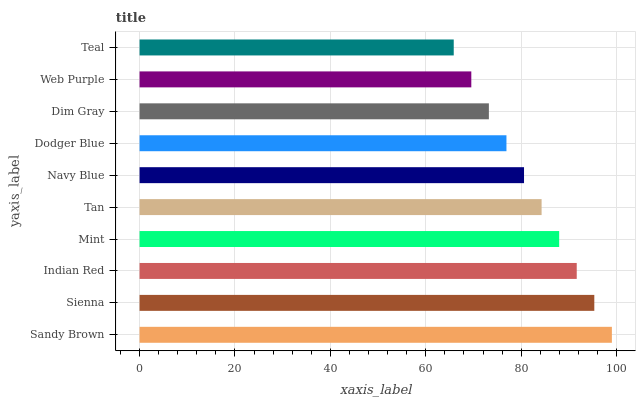Is Teal the minimum?
Answer yes or no. Yes. Is Sandy Brown the maximum?
Answer yes or no. Yes. Is Sienna the minimum?
Answer yes or no. No. Is Sienna the maximum?
Answer yes or no. No. Is Sandy Brown greater than Sienna?
Answer yes or no. Yes. Is Sienna less than Sandy Brown?
Answer yes or no. Yes. Is Sienna greater than Sandy Brown?
Answer yes or no. No. Is Sandy Brown less than Sienna?
Answer yes or no. No. Is Tan the high median?
Answer yes or no. Yes. Is Navy Blue the low median?
Answer yes or no. Yes. Is Dodger Blue the high median?
Answer yes or no. No. Is Tan the low median?
Answer yes or no. No. 